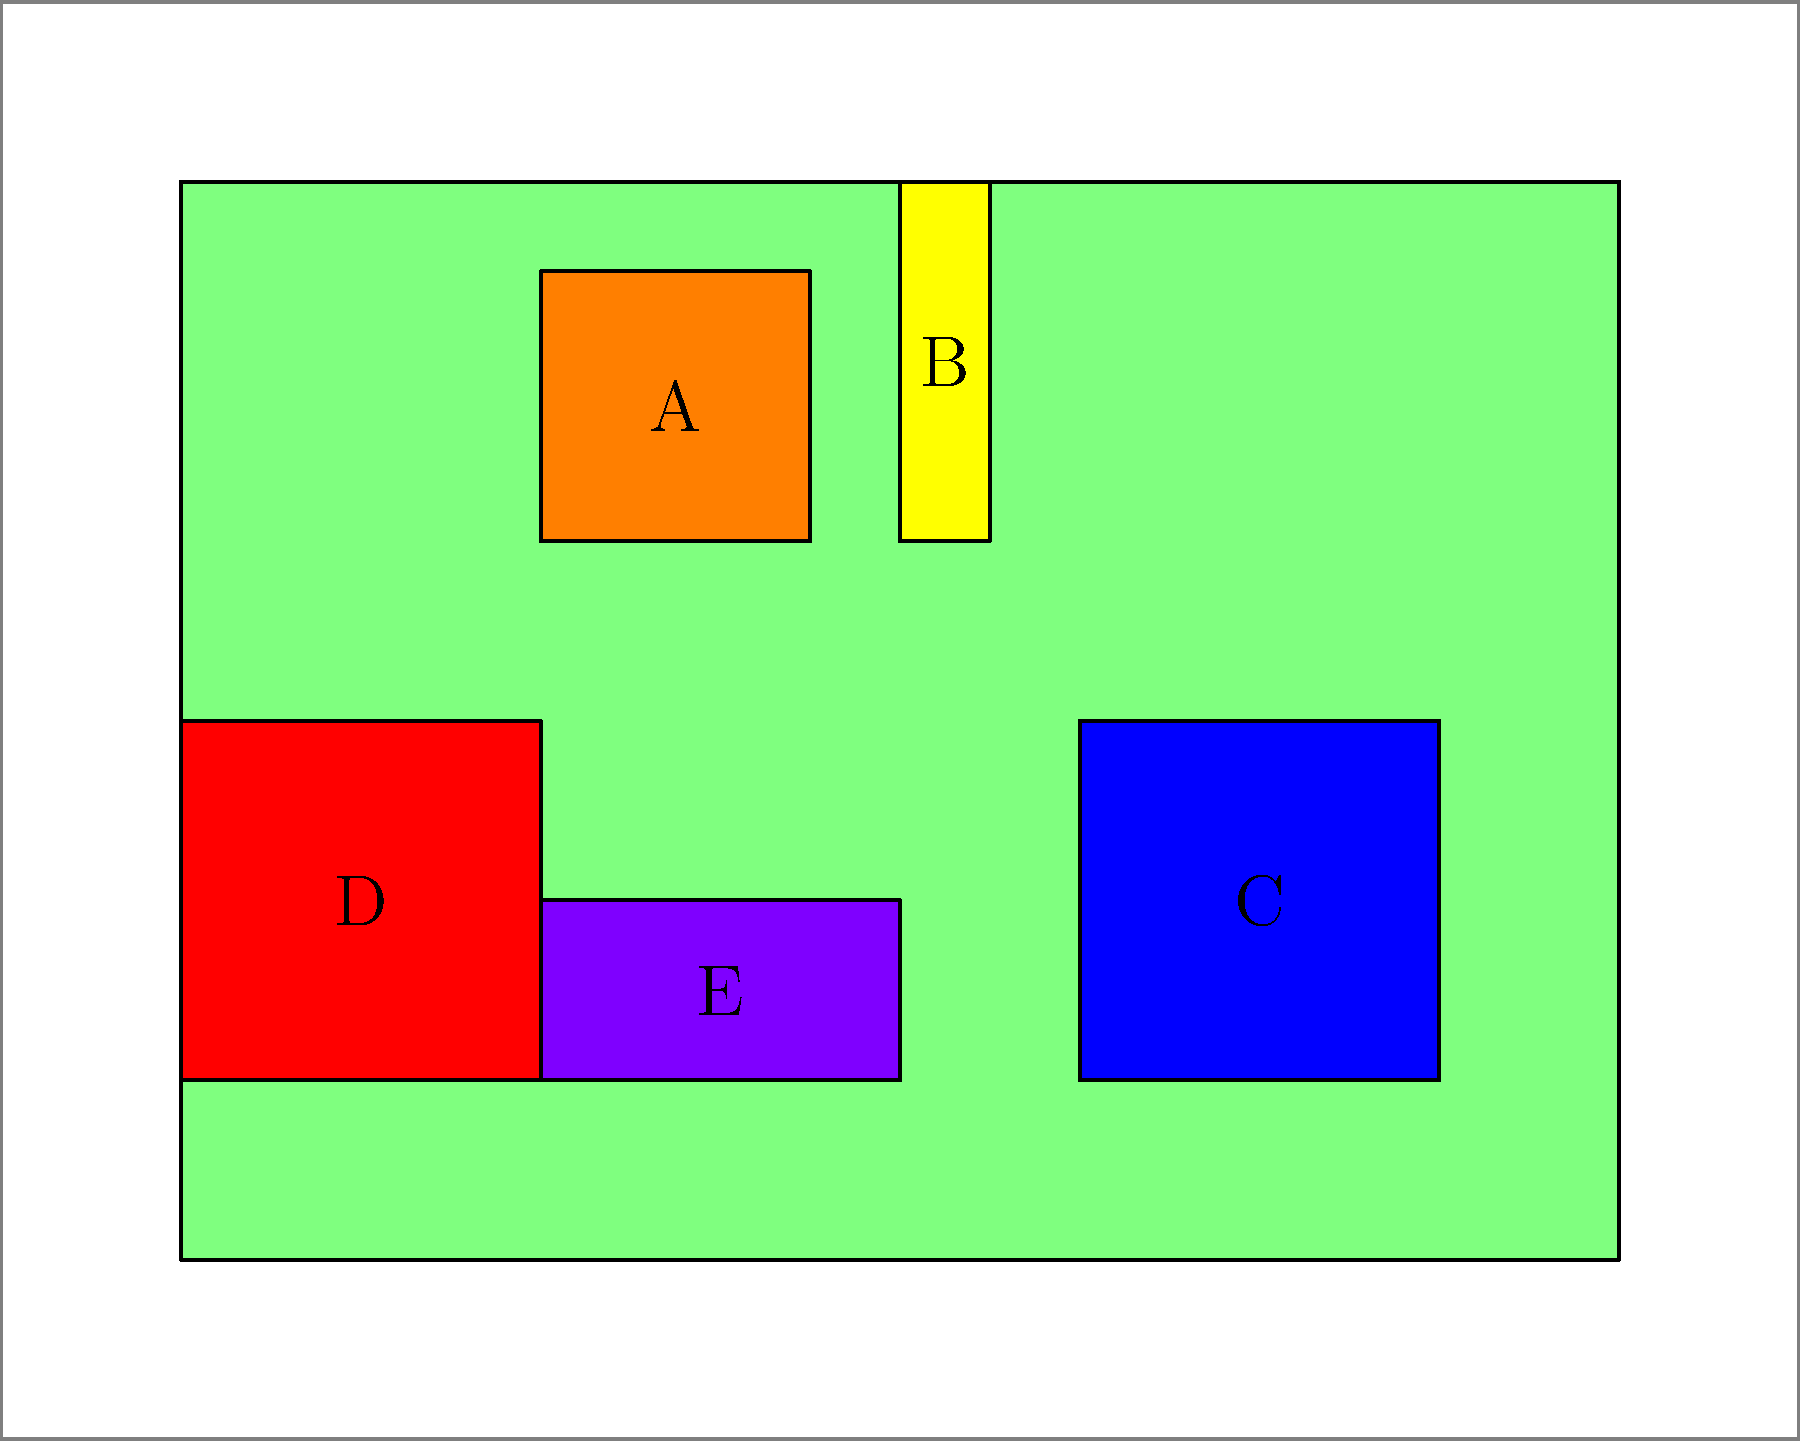As a cybersecurity expert, you understand the importance of identifying computer components quickly. In the diagram above, which component labeled A-E represents the Central Processing Unit (CPU)? To answer this question, we need to analyze each labeled component and identify which one matches the characteristics of a CPU:

1. Component A: This is a square-shaped component located near the center of the motherboard. Its size and position are typical of a CPU in a computer system.

2. Component B: This is a narrow, rectangular component. Its shape and position suggest it's likely a RAM stick.

3. Component C: This larger rectangular component is positioned away from the center. Its size and location indicate it's probably a hard drive.

4. Component D: This component is located in the corner of the case. Its position and size suggest it's likely a power supply unit.

5. Component E: This long, thin component attached to the motherboard is characteristic of a graphics card.

Given these observations, the component that best matches the characteristics of a CPU is component A. It's in the correct position on the motherboard and has the appropriate size and shape for a modern CPU.
Answer: A 